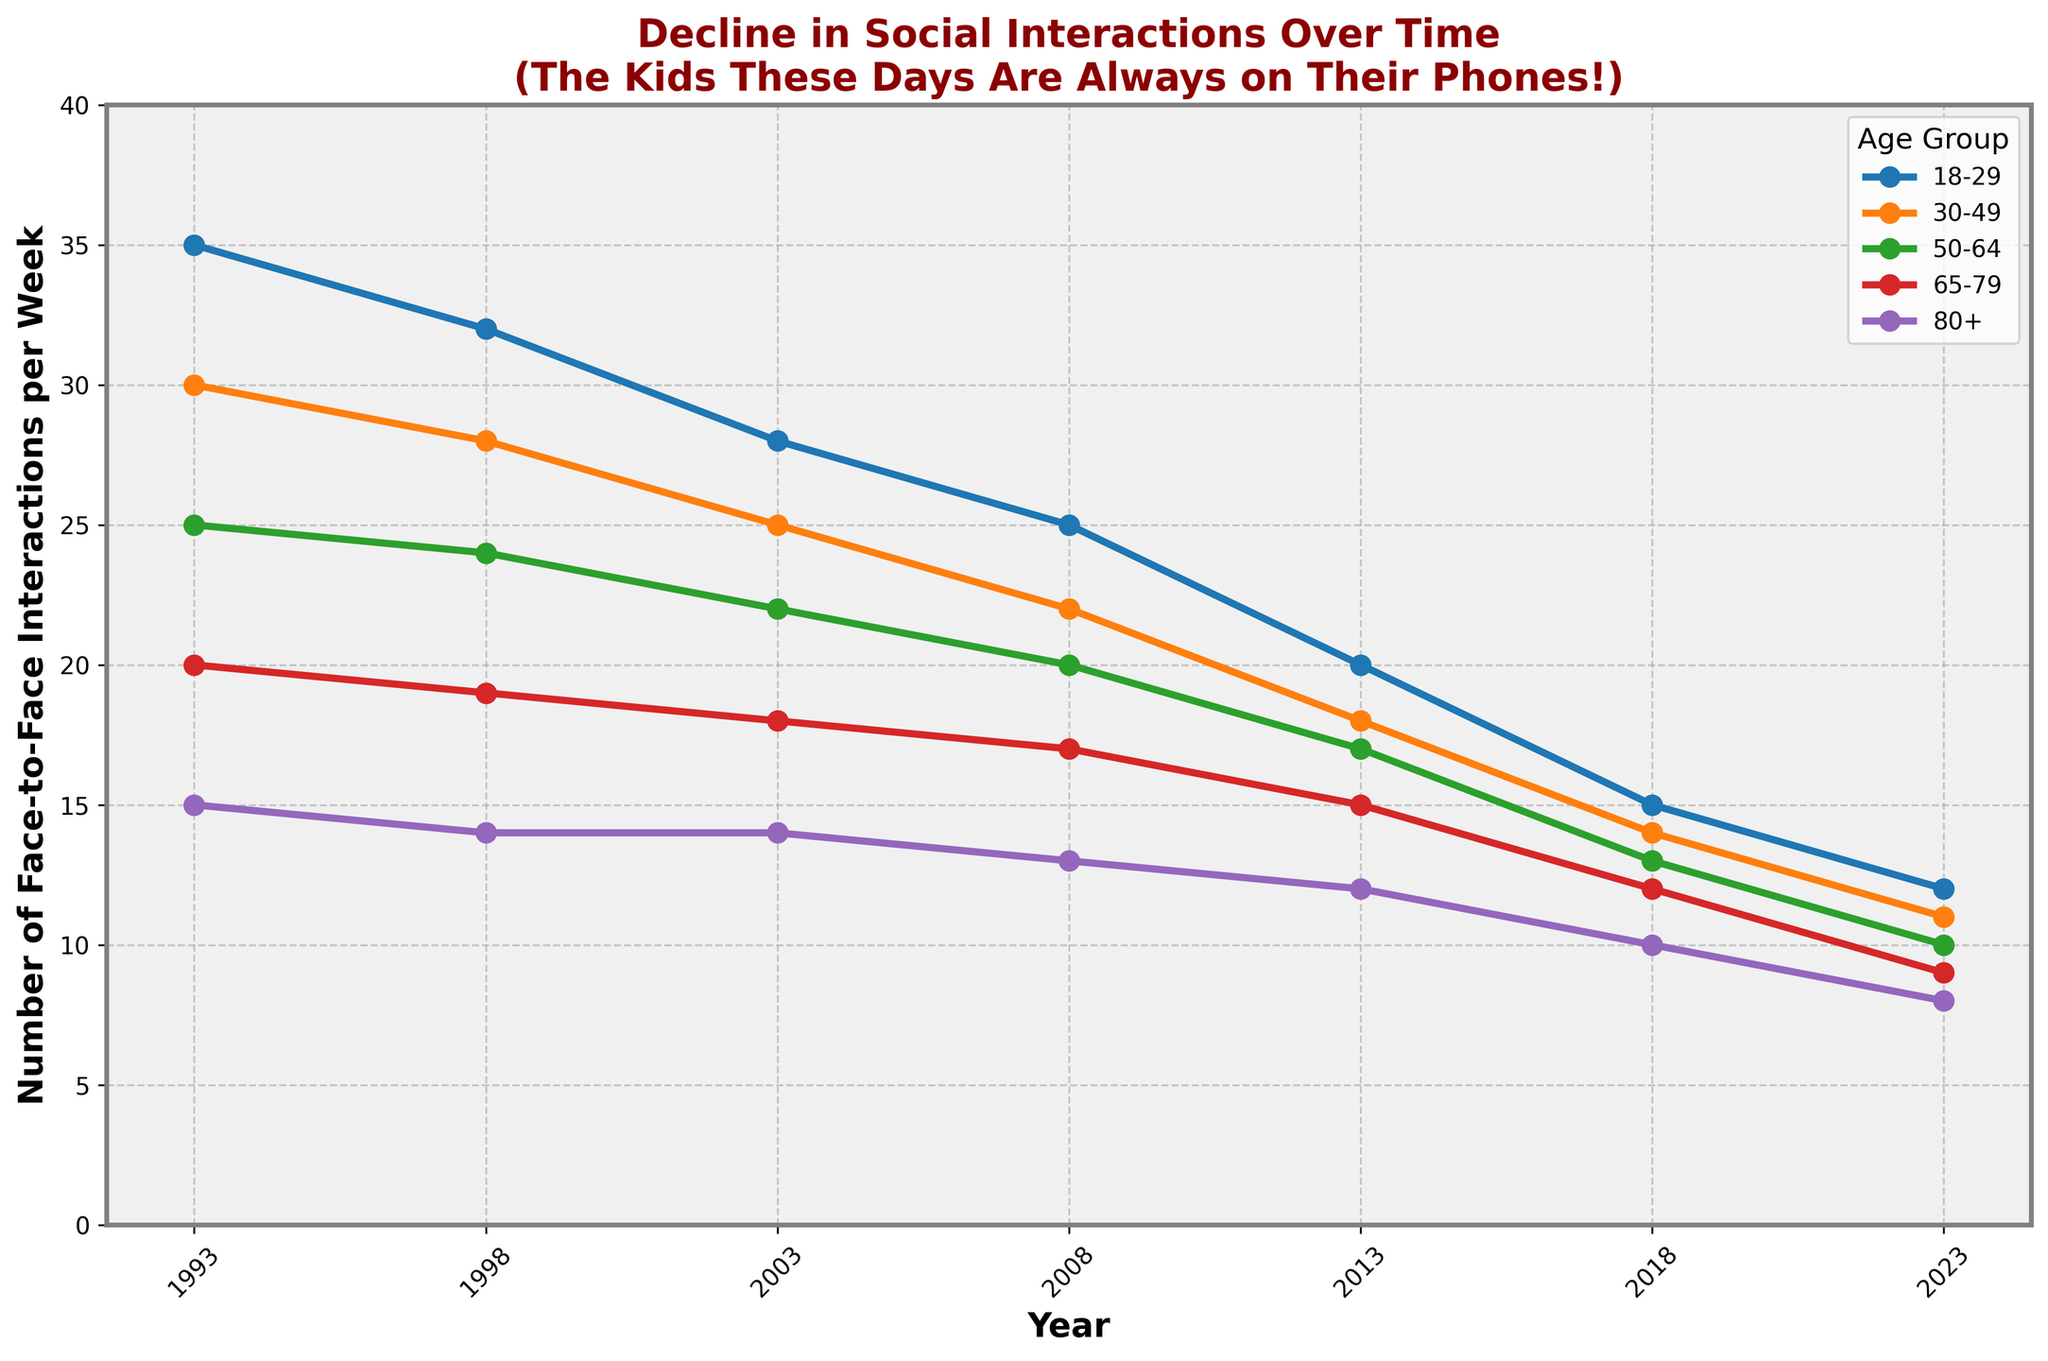Which age group had the highest number of face-to-face interactions in 1993? The data shows the number of interactions per week for each age group in 1993. The 18-29 age group had the highest value at 35.
Answer: 18-29 What is the overall decrease in face-to-face interactions for the 50-64 age group from 1993 to 2023? In 1993, the 50-64 age group had 25 interactions, and in 2023, it had 10. The decrease is 25 - 10 = 15.
Answer: 15 Between which consecutive years did the 30-49 age group see the largest drop in interactions? By comparing the differences between consecutive years, the largest drop for the 30-49 age group is between 2013 and 2018, where the number dropped from 18 to 14, a decrease of 4.
Answer: 2013 to 2018 Which age group saw the least amount of decline in interactions over the 30-year period? Calculating the difference for each age group from 1993 to 2023 shows that the 80+ age group had the smallest decline (15 - 8 = 7).
Answer: 80+ What is the average number of interactions for the 65-79 age group across the entire 30-year period? Summing the values (20 + 19 + 18 + 17 + 15 + 12 + 9) gives 110. There are 7 data points, so the average is 110 / 7 ≈ 15.71.
Answer: 15.71 Which age group had more interactions in 2018: 30-49 or 50-64? Observing the 2018 data shows the values: 30-49 had 14 interactions, while 50-64 had 13.
Answer: 30-49 By how much did the interactions in the 18-29 age group drop from 2003 to 2023? The data shows interactions for 2003 were 28 and for 2023 were 12. The drop is 28 - 12 = 16.
Answer: 16 Compare the trend in the number of interactions for the 65-79 age group with that of the 80+ age group. Which interesting pattern can you observe? Both age groups show a steady decline. However, the rate of decline in the 80+ age group is smaller, dropping by only 7 interactions over 30 years compared to 11 in the 65-79 age group.
Answer: Smaller decline for 80+ Which year had the smallest difference in interactions between the 18-29 and 80+ age groups? In 2023, the 18-29 group had 12 interactions, and the 80+ group had 8, giving a difference of 4, which is the smallest observed.
Answer: 2023 What can you infer about social interactions for younger people (18-29) compared to older people (80+) over the last 30 years? Interactions for younger people (18-29) decreased more dramatically over 30 years compared to older people (80+). The 18-29 age group started at 35 and ended at 12, a 23-point drop, while the 80+ group dropped from 15 to 8, a 7-point drop, indicating a sharper decline for younger people.
Answer: Sharper decline for younger people 